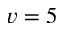Convert formula to latex. <formula><loc_0><loc_0><loc_500><loc_500>v = 5</formula> 